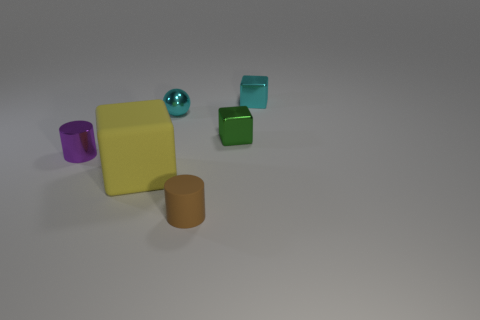Describe the sizes and shapes of the objects in the image. The photo showcases objects of varying sizes and shapes: there is one large yellow square block, one medium-sized purple cylinder, a tiny glossy green sphere, a small green cube, a small turquoise cube, and a medium-sized brown cylinder. 